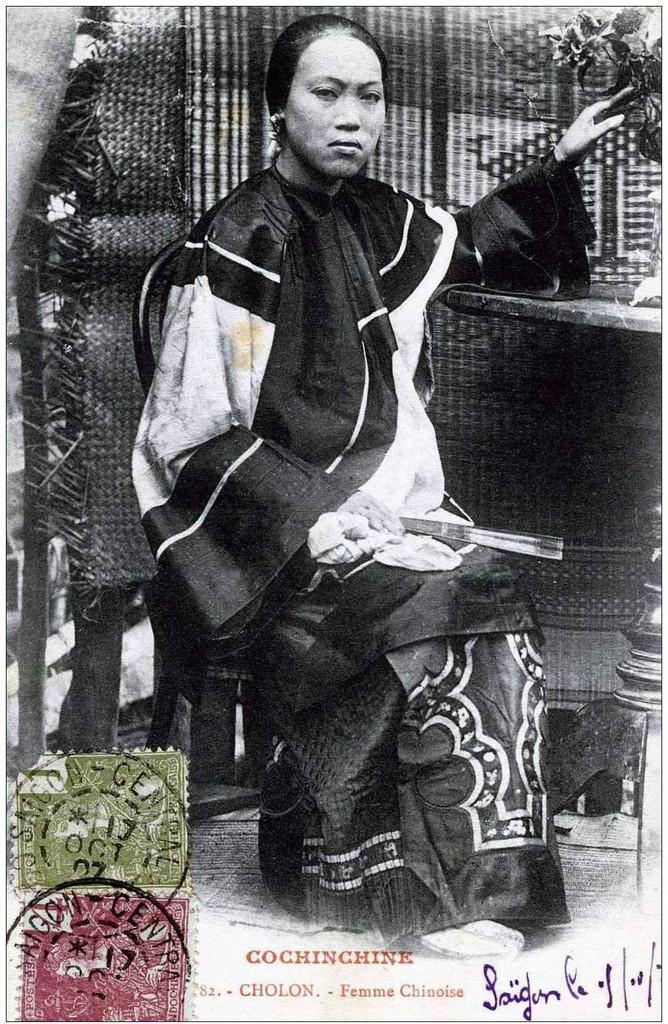How would you summarize this image in a sentence or two? In this picture we can see the poster. In the poster there is a woman who is sitting on the chair, beside her we can see plant, pot on the table. At the bottom we can see the stamps and signature. Behind her we can see a wooden wall and trees. 